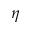Convert formula to latex. <formula><loc_0><loc_0><loc_500><loc_500>\eta</formula> 